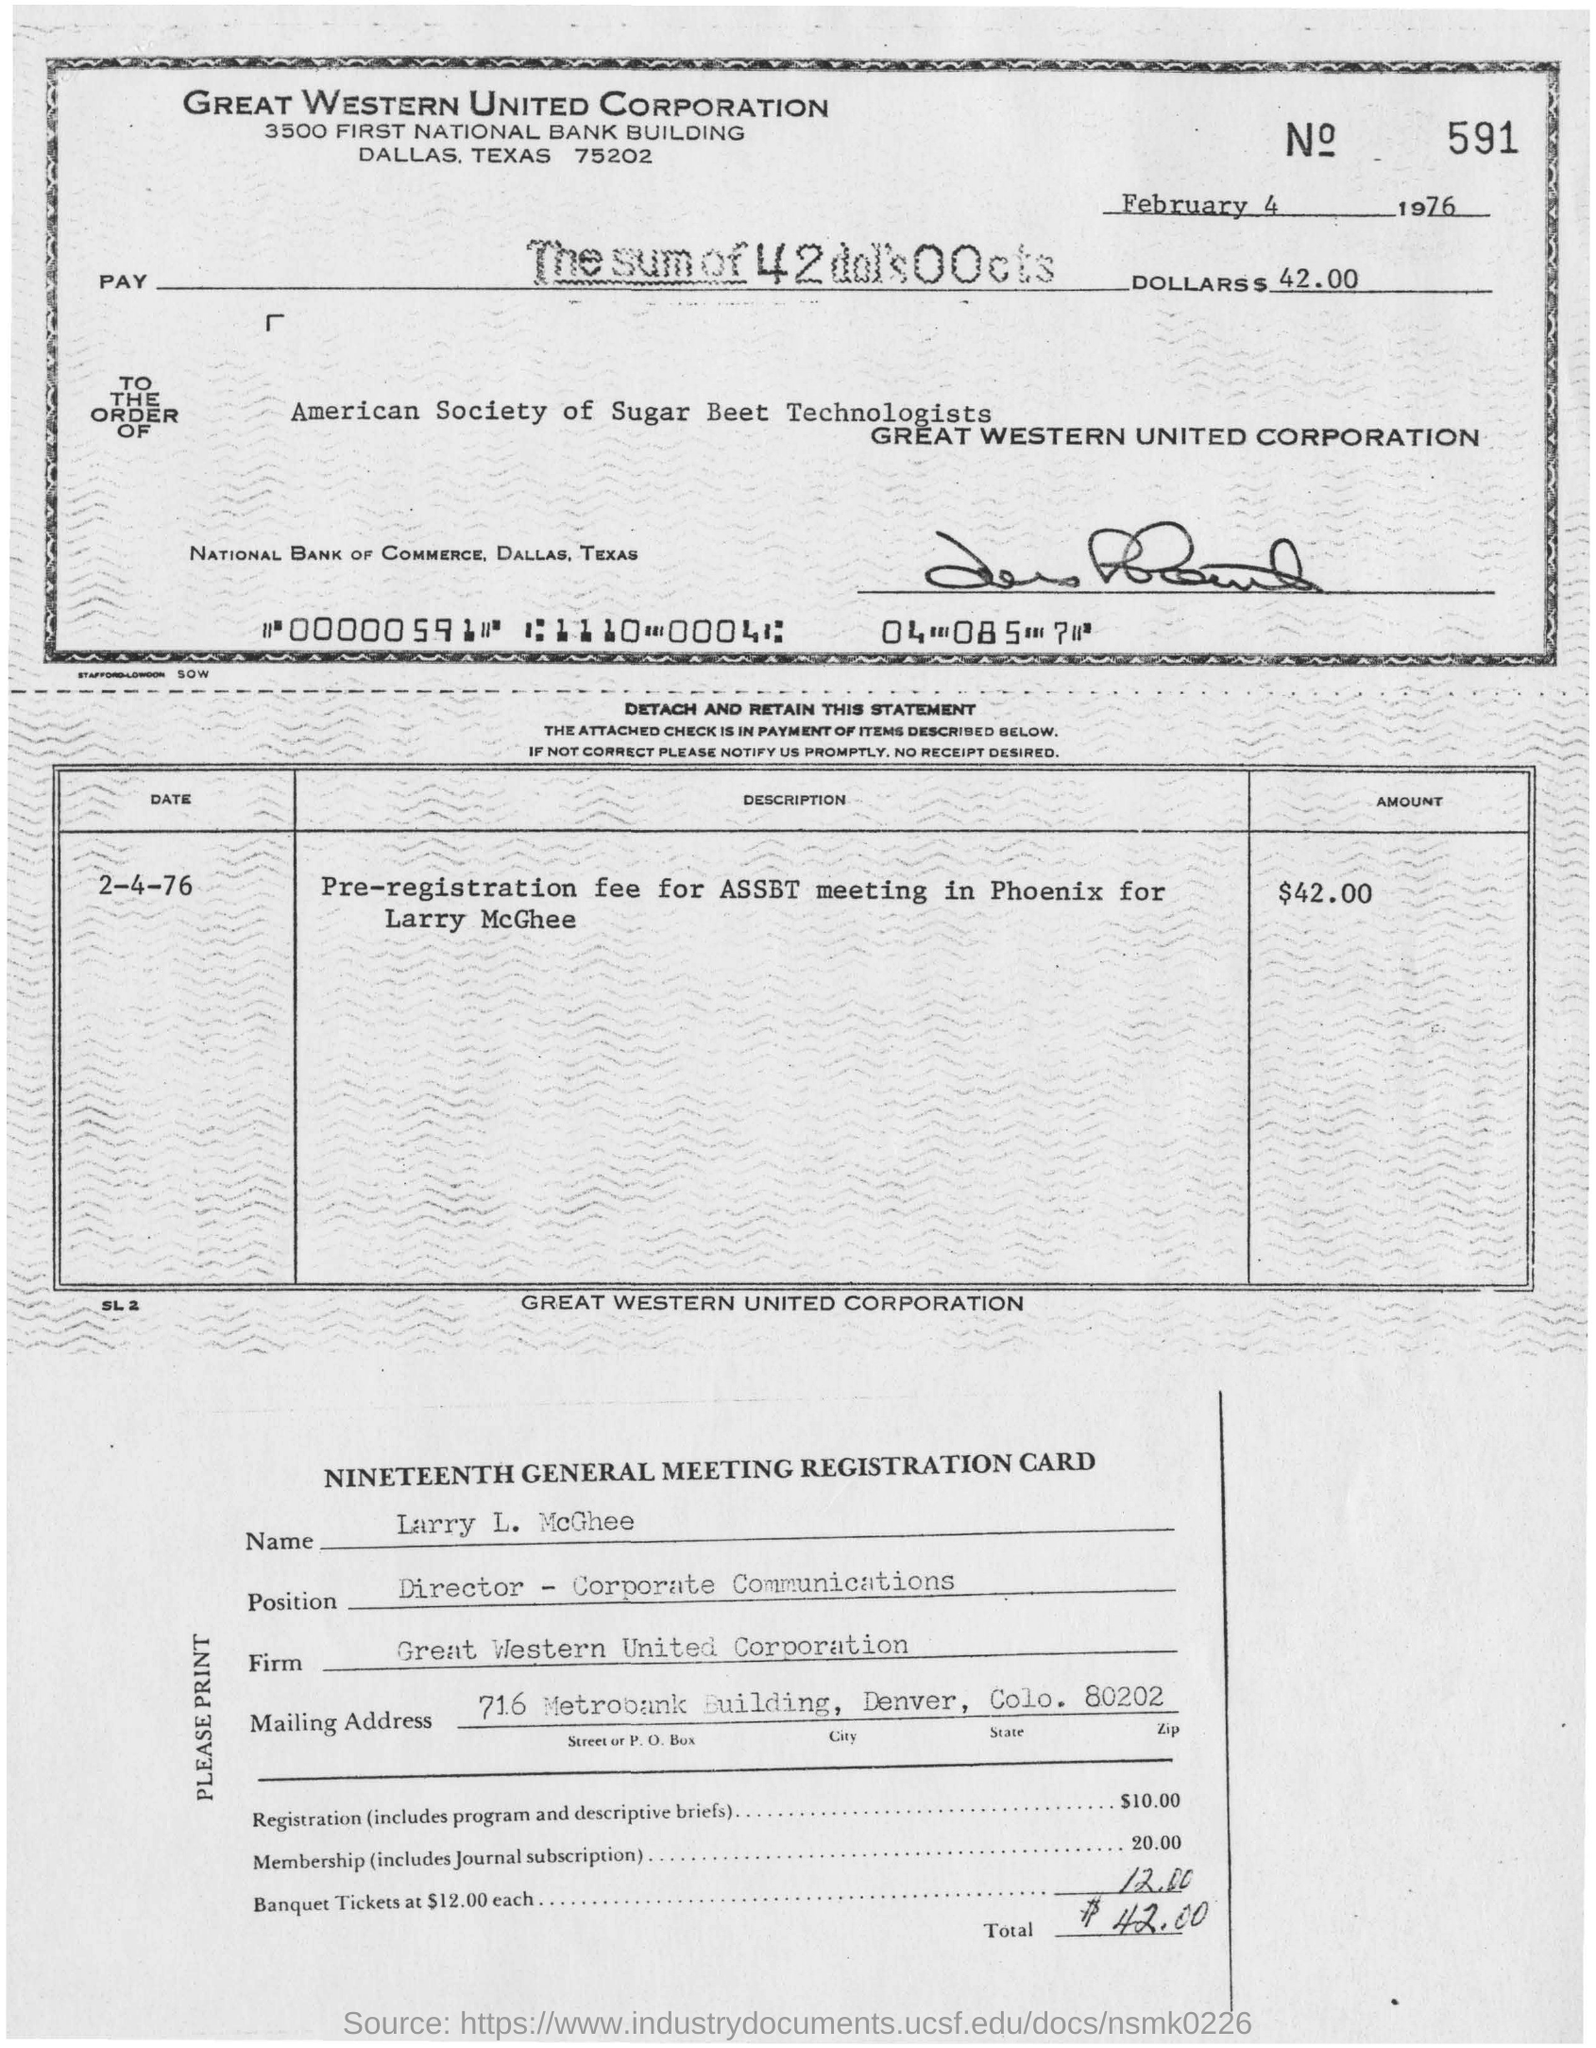What is the name of the corporation in the check?
Ensure brevity in your answer.  GREAT WESTERN UNITED CORPORATION. What is the date in the check?
Your answer should be compact. February 4 1976. What is the name mentioned in the nineteenth general meeting registration card?
Offer a terse response. Larry L. McGhee. The check is ordered to which company?
Give a very brief answer. American Society of Sugar Beet Technologists. What is the date in the statement ?
Your answer should be compact. 2-4-76. What is in the description?
Your response must be concise. Pre-registration fee for assbt meeting in phoenix for larry mcghee. What is the larry l. mcghee position?
Provide a short and direct response. Director - corporate communications. Who's name in the nineteenth general meeting registration card?
Make the answer very short. Larry l. mcghee. 